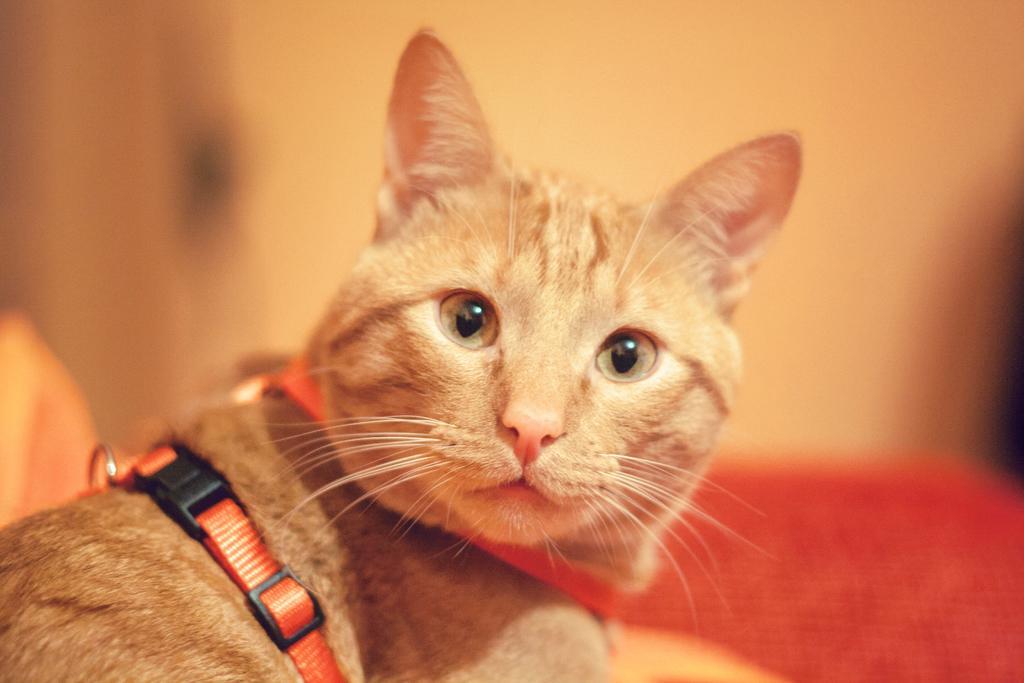Please provide a concise description of this image. In this image I can see a cat which is brown and cream in color. I can see a belt to it which is orange and black in color. I can see the blurry background. 